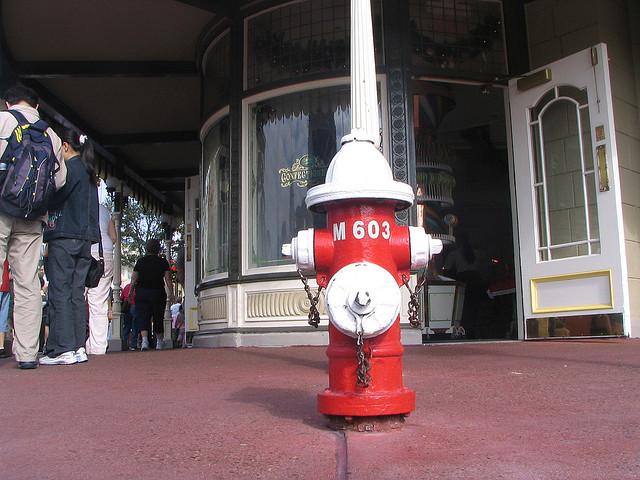What is the number on the fire hydrant?
Answer briefly. 603. What is the main color of the door?
Quick response, please. White. What kind of store is behind the hydrant?
Answer briefly. Boutique. 